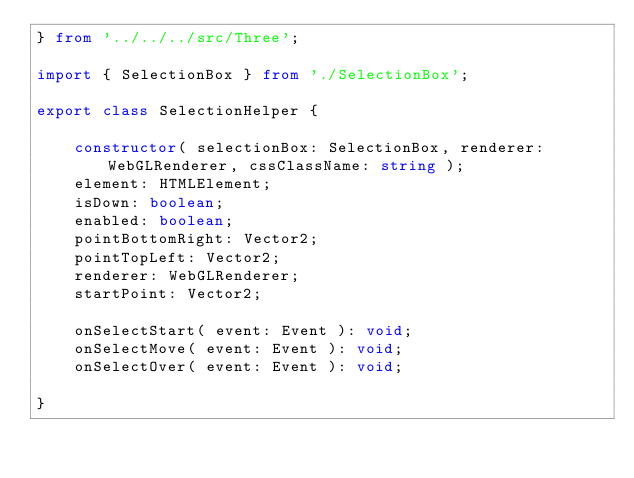<code> <loc_0><loc_0><loc_500><loc_500><_TypeScript_>} from '../../../src/Three';

import { SelectionBox } from './SelectionBox';

export class SelectionHelper {

	constructor( selectionBox: SelectionBox, renderer: WebGLRenderer, cssClassName: string );
	element: HTMLElement;
	isDown: boolean;
	enabled: boolean;
	pointBottomRight: Vector2;
	pointTopLeft: Vector2;
	renderer: WebGLRenderer;
	startPoint: Vector2;

	onSelectStart( event: Event ): void;
	onSelectMove( event: Event ): void;
	onSelectOver( event: Event ): void;

}
</code> 